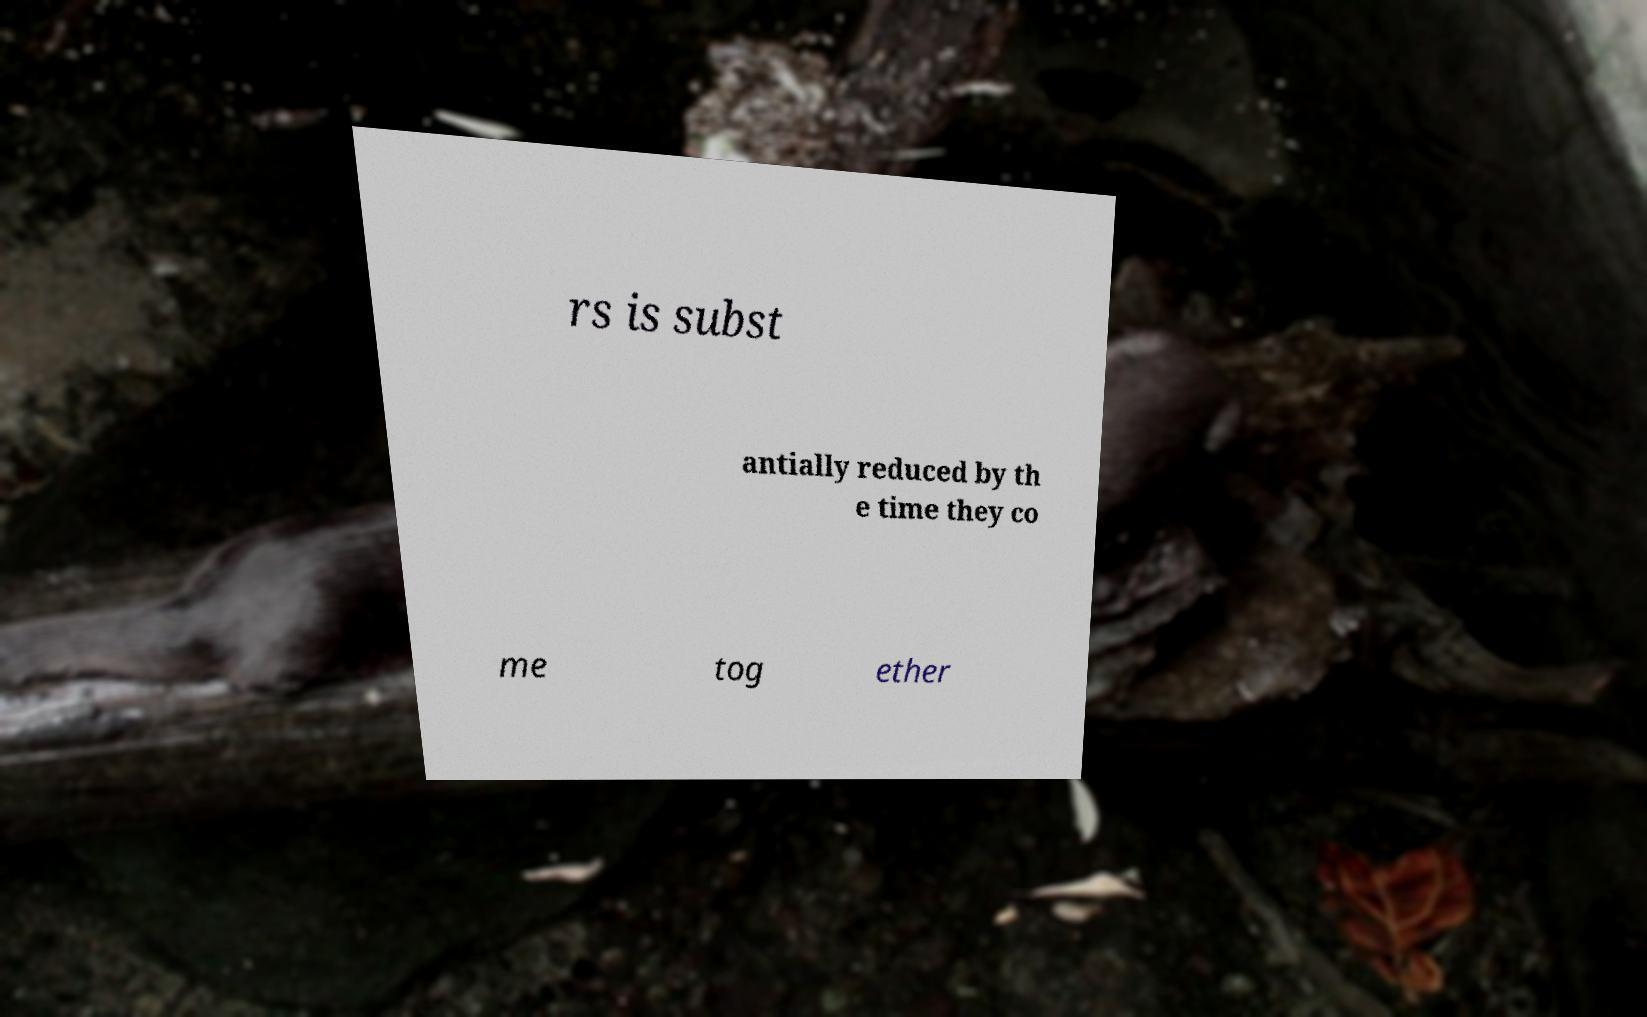What messages or text are displayed in this image? I need them in a readable, typed format. rs is subst antially reduced by th e time they co me tog ether 